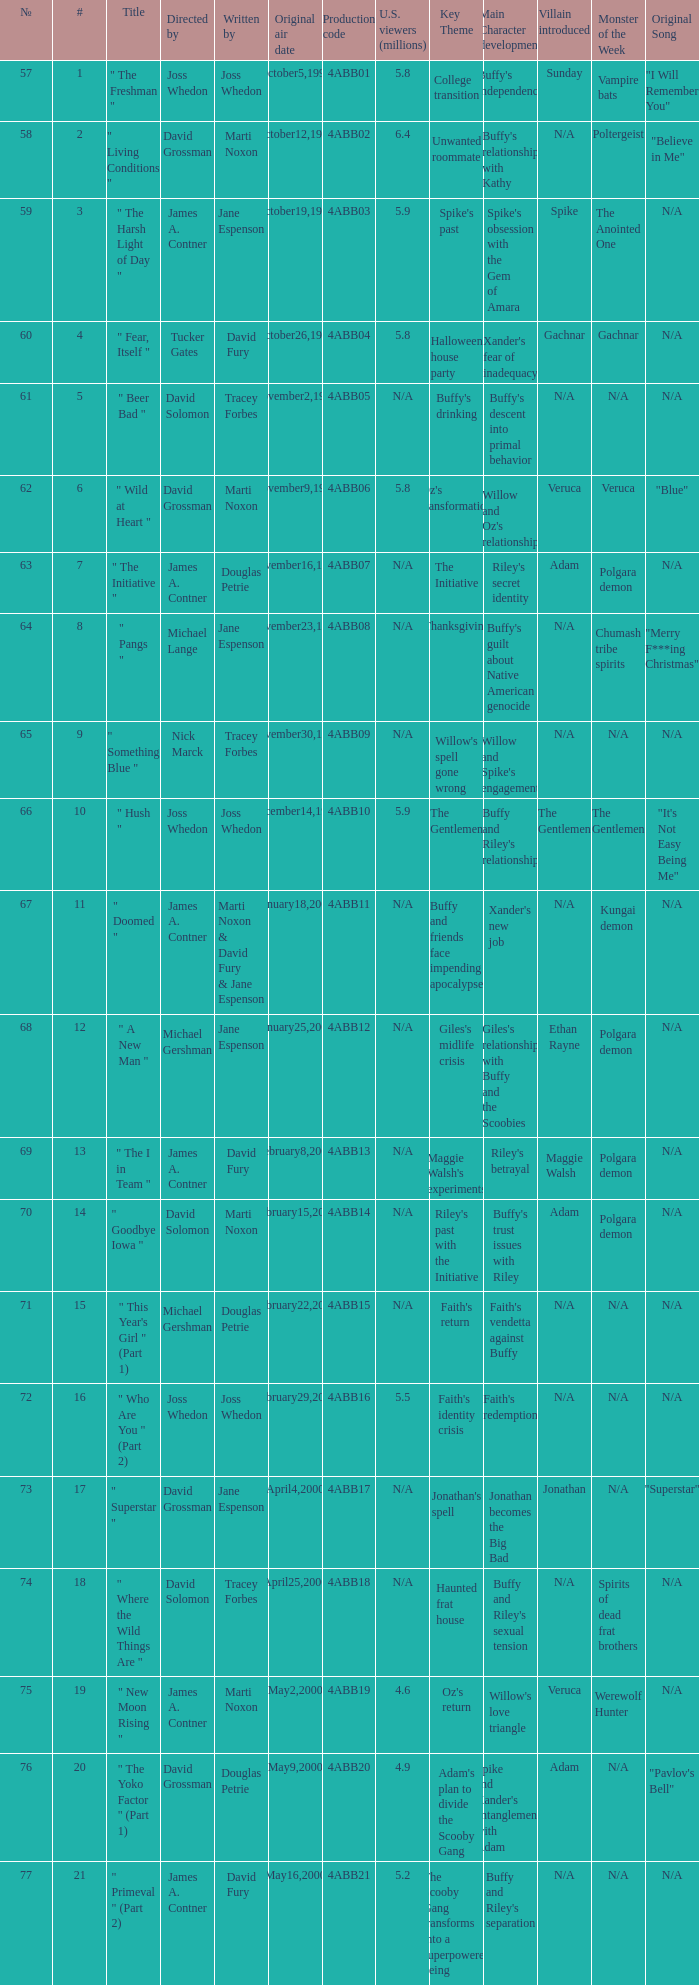What is the season 4 # for the production code of 4abb07? 7.0. 